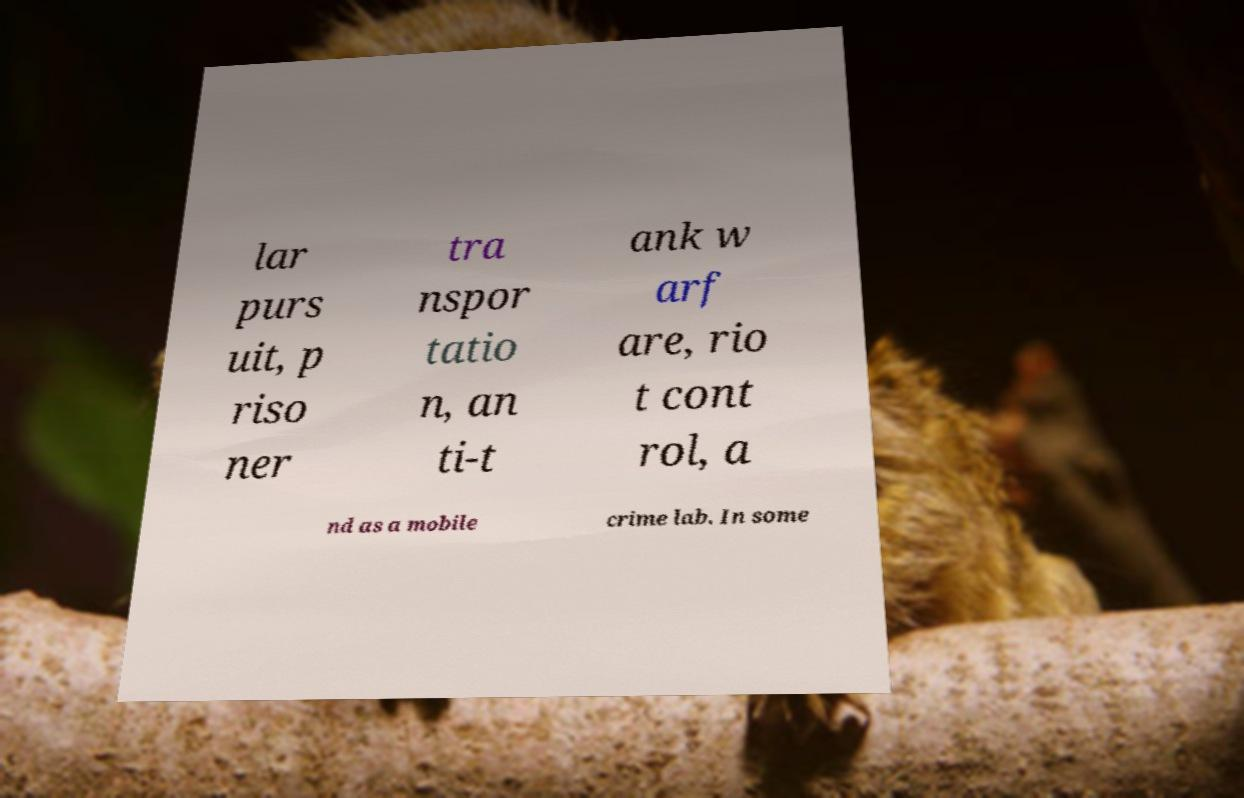Please read and relay the text visible in this image. What does it say? lar purs uit, p riso ner tra nspor tatio n, an ti-t ank w arf are, rio t cont rol, a nd as a mobile crime lab. In some 